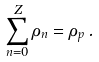Convert formula to latex. <formula><loc_0><loc_0><loc_500><loc_500>\sum _ { n = 0 } ^ { Z } \rho _ { n } = \rho _ { p } \, .</formula> 